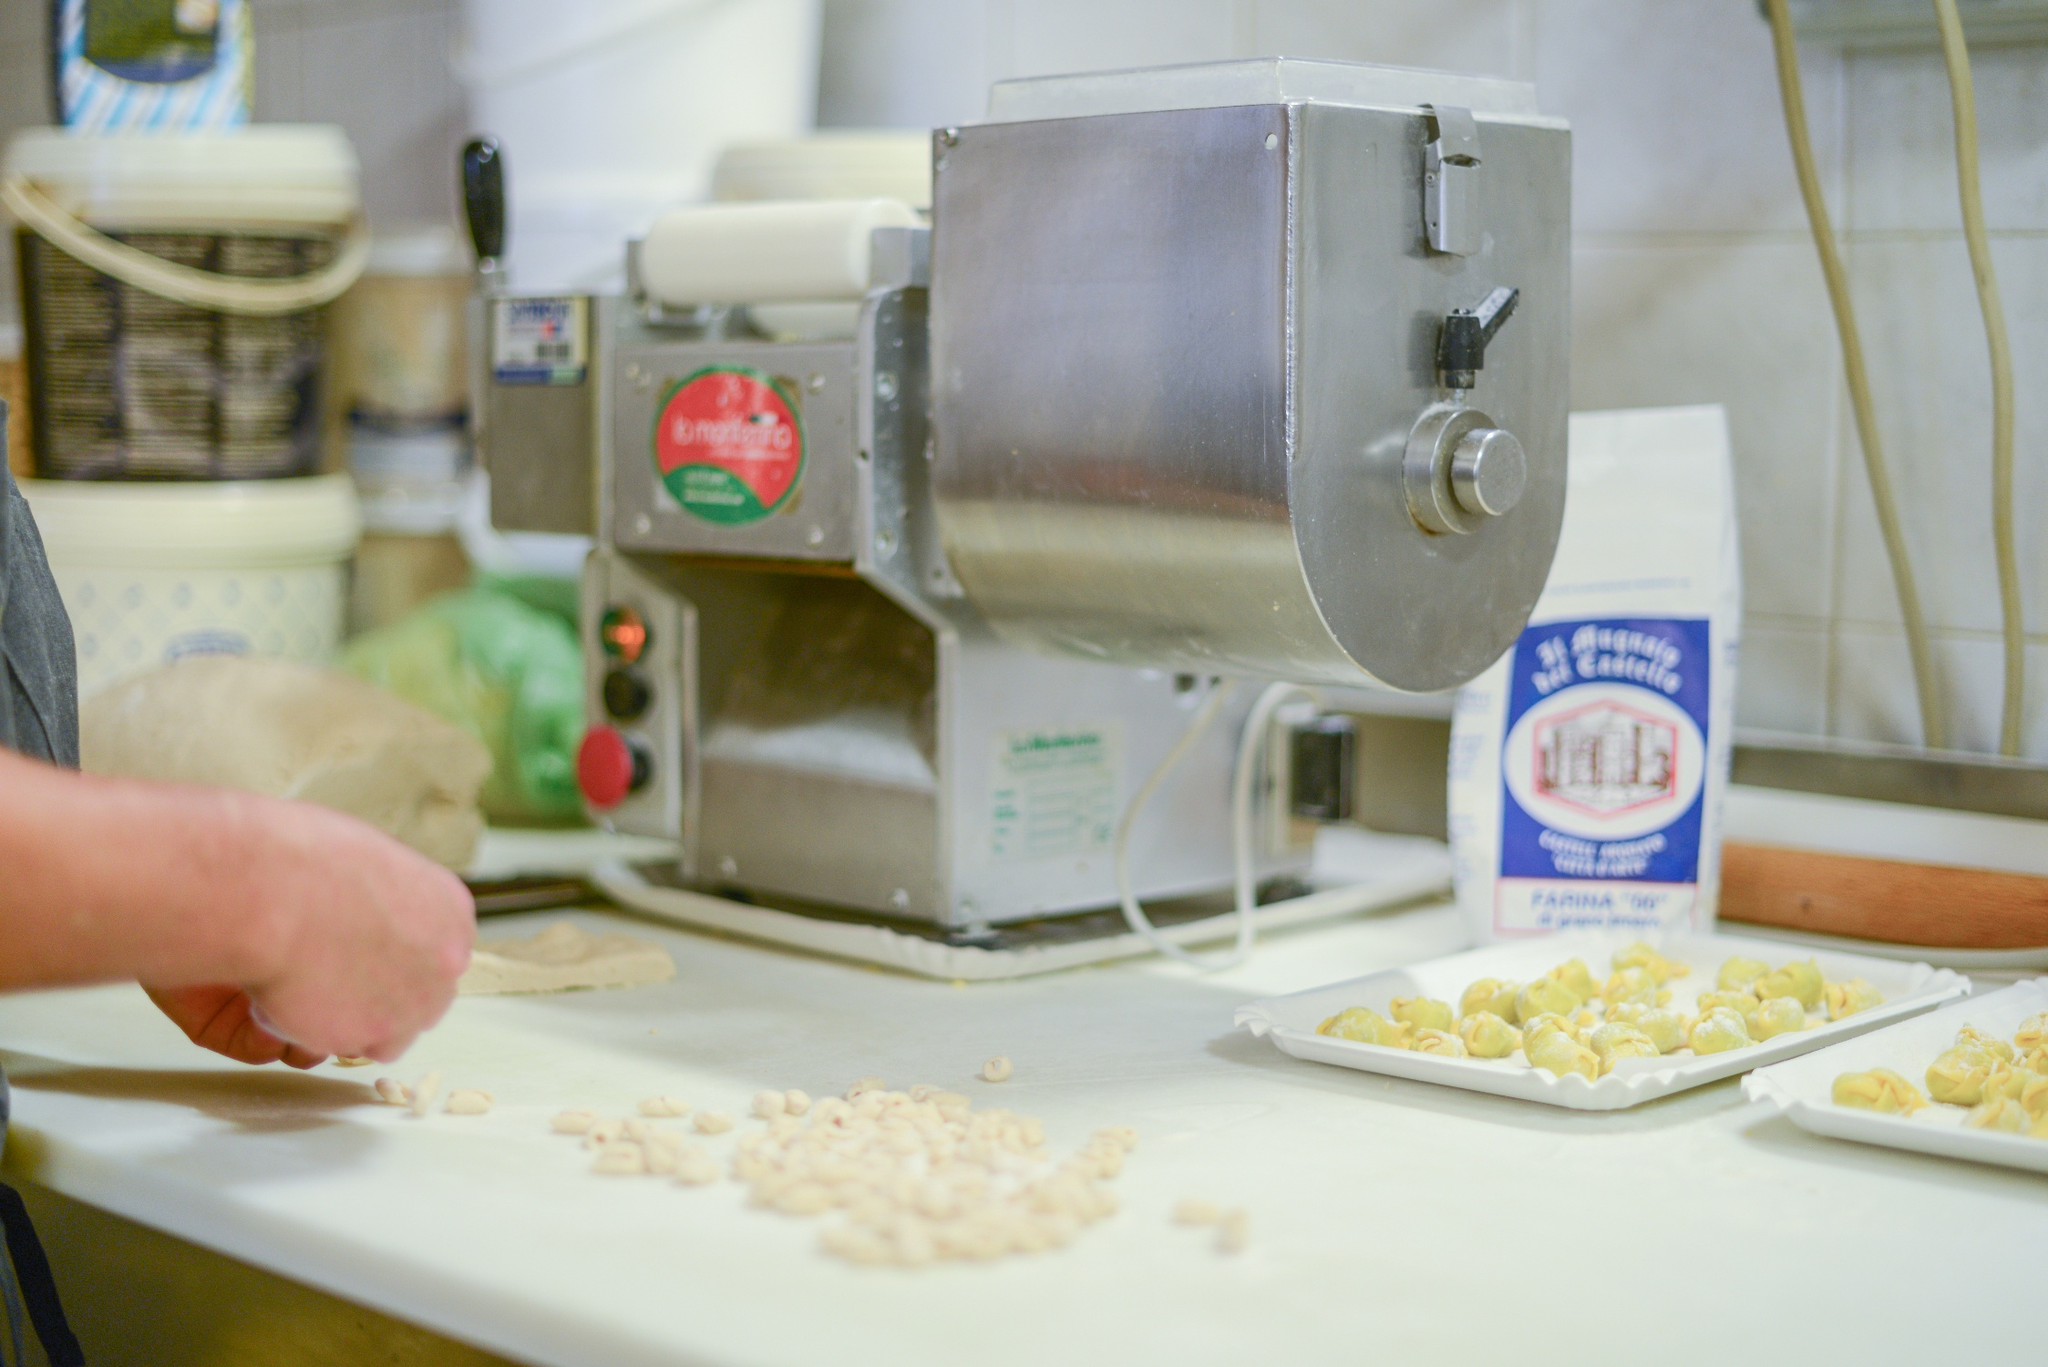How does the setting contribute to the overall ambiance of the scene? The setting of this kitchen is quintessential to its charm and ambiance. The white tiled walls evoke a sense of cleanliness and order, while the well-organized shelves brimming with kitchen essentials add a warm, lived-in feel. The focal point, the pasta machine with its retro red 'La monferrina' label, speaks of tradition and quality in pasta making. The countertop, uncluttered yet functional, allows ample space for crafting pasta, emphasizing the hands-on, artisanal approach. Together, these elements create an atmosphere that is both inviting and inspiring for culinary creativity. 